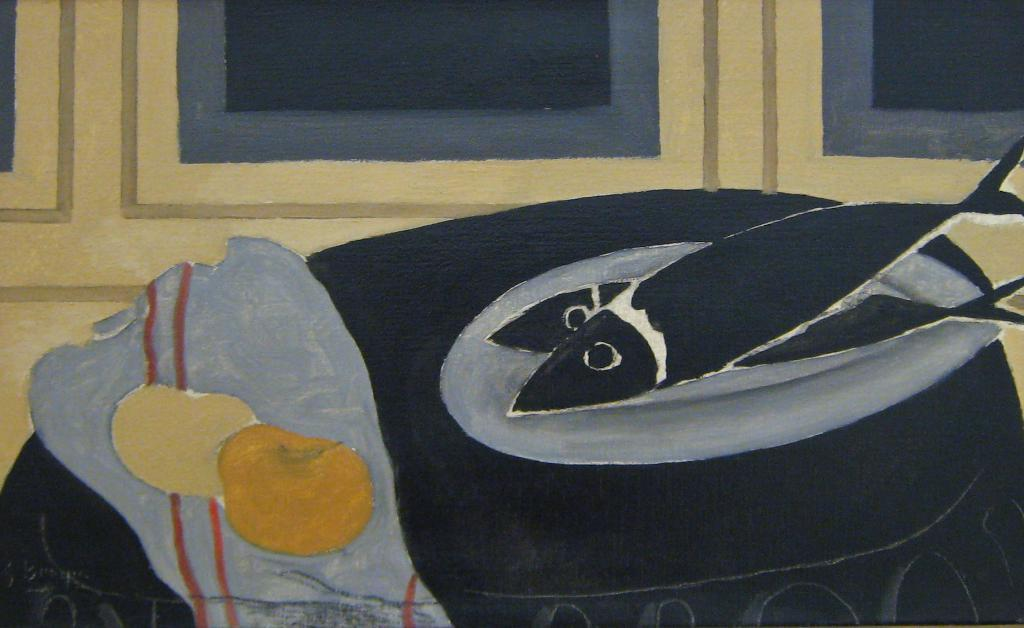What type of artwork is depicted in the image? The image is a painting. What architectural feature can be seen in the painting? There are windows in the painting. What type of animals are present in the painting? There are fishes in the painting. What object made of fabric is in the painting? There is a cloth in the painting. What industry is represented by the parent in the painting? There is no parent or industry depicted in the painting; it features windows, fishes, and a cloth. What type of root can be seen growing from the cloth in the painting? There are no roots present in the painting; it only features a cloth. 